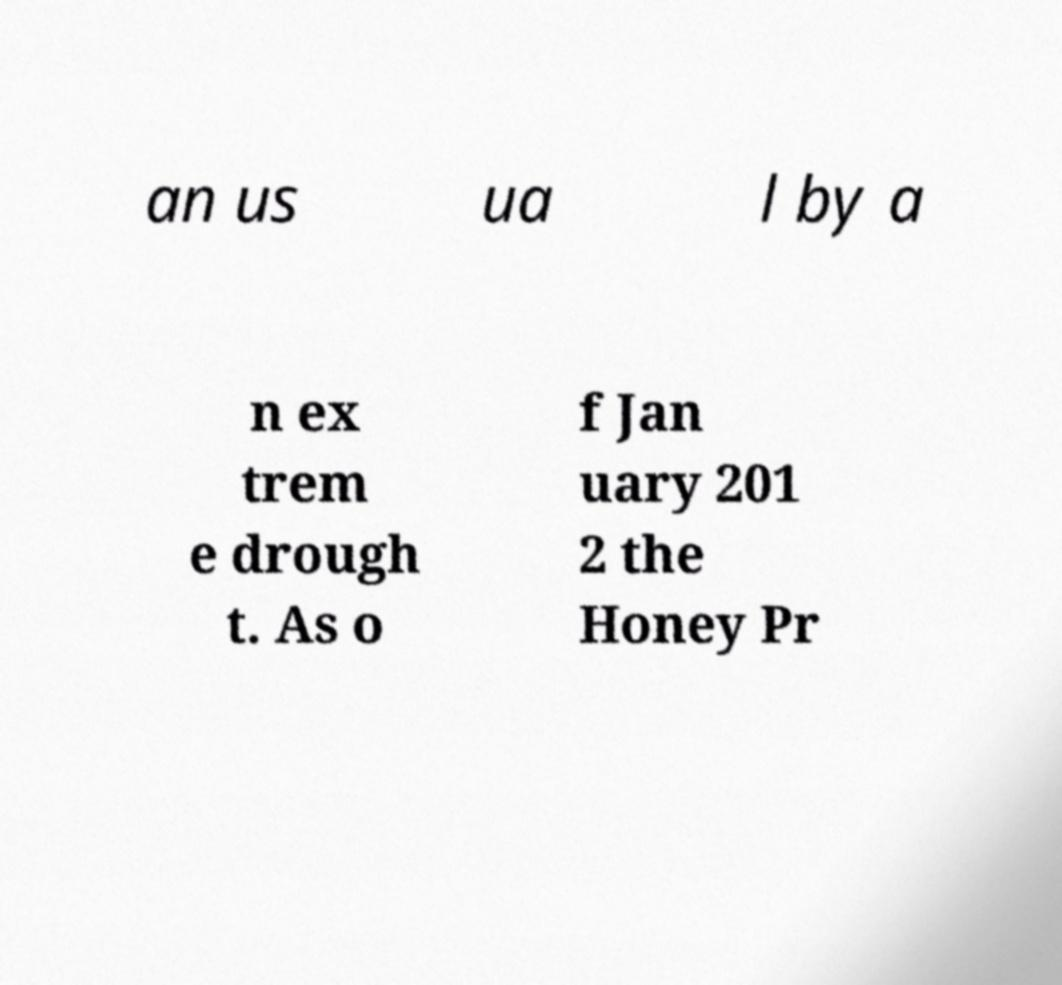What messages or text are displayed in this image? I need them in a readable, typed format. an us ua l by a n ex trem e drough t. As o f Jan uary 201 2 the Honey Pr 